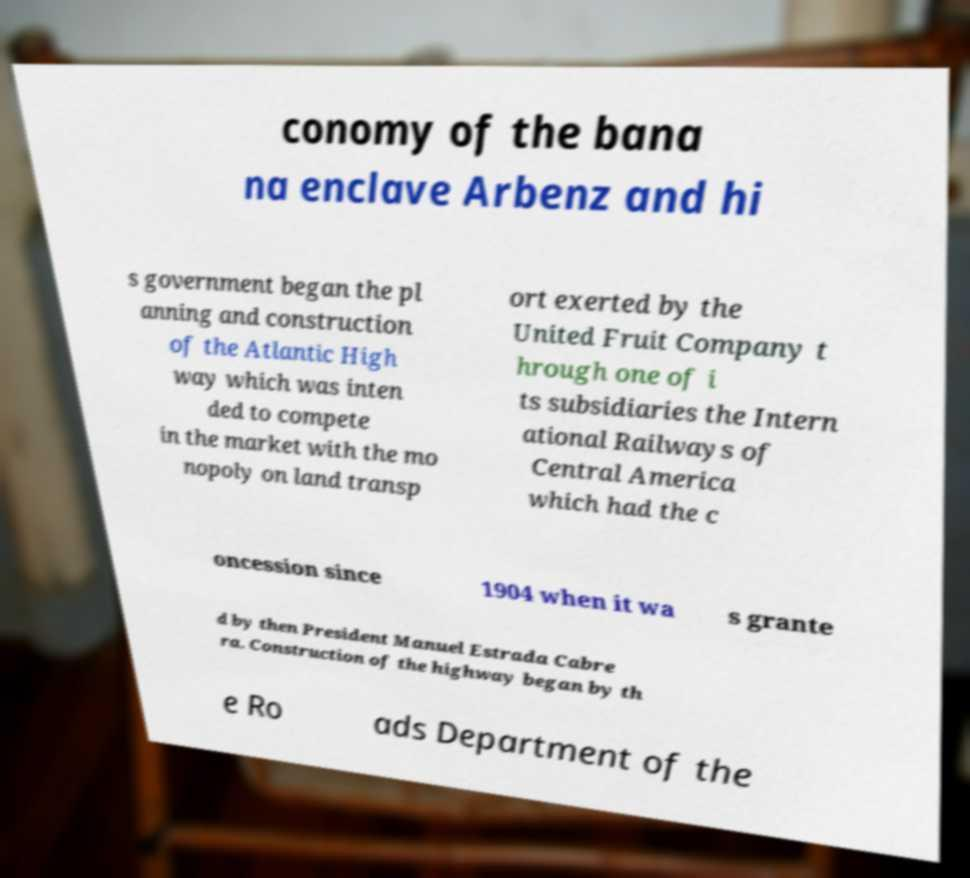I need the written content from this picture converted into text. Can you do that? conomy of the bana na enclave Arbenz and hi s government began the pl anning and construction of the Atlantic High way which was inten ded to compete in the market with the mo nopoly on land transp ort exerted by the United Fruit Company t hrough one of i ts subsidiaries the Intern ational Railways of Central America which had the c oncession since 1904 when it wa s grante d by then President Manuel Estrada Cabre ra. Construction of the highway began by th e Ro ads Department of the 